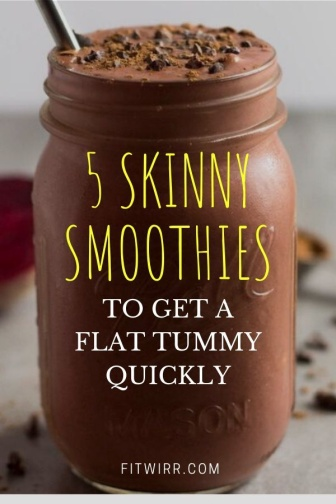What are the nutritional implications of the smoothie in the image? The image suggests that the smoothie is a part of a dietary plan aimed at promoting a flat tummy, which implies it may be low in calories and high in nutrients that support weight management. Ingredients typically found in 'skinny smoothies' often include a blend of fruits, vegetables, and sometimes protein sources, tailored to increase fiber intake, enhance satiety, and help with digestion. However, without specific information on the ingredients of this particular smoothie, one can only speculate on the full nutritional profile. 